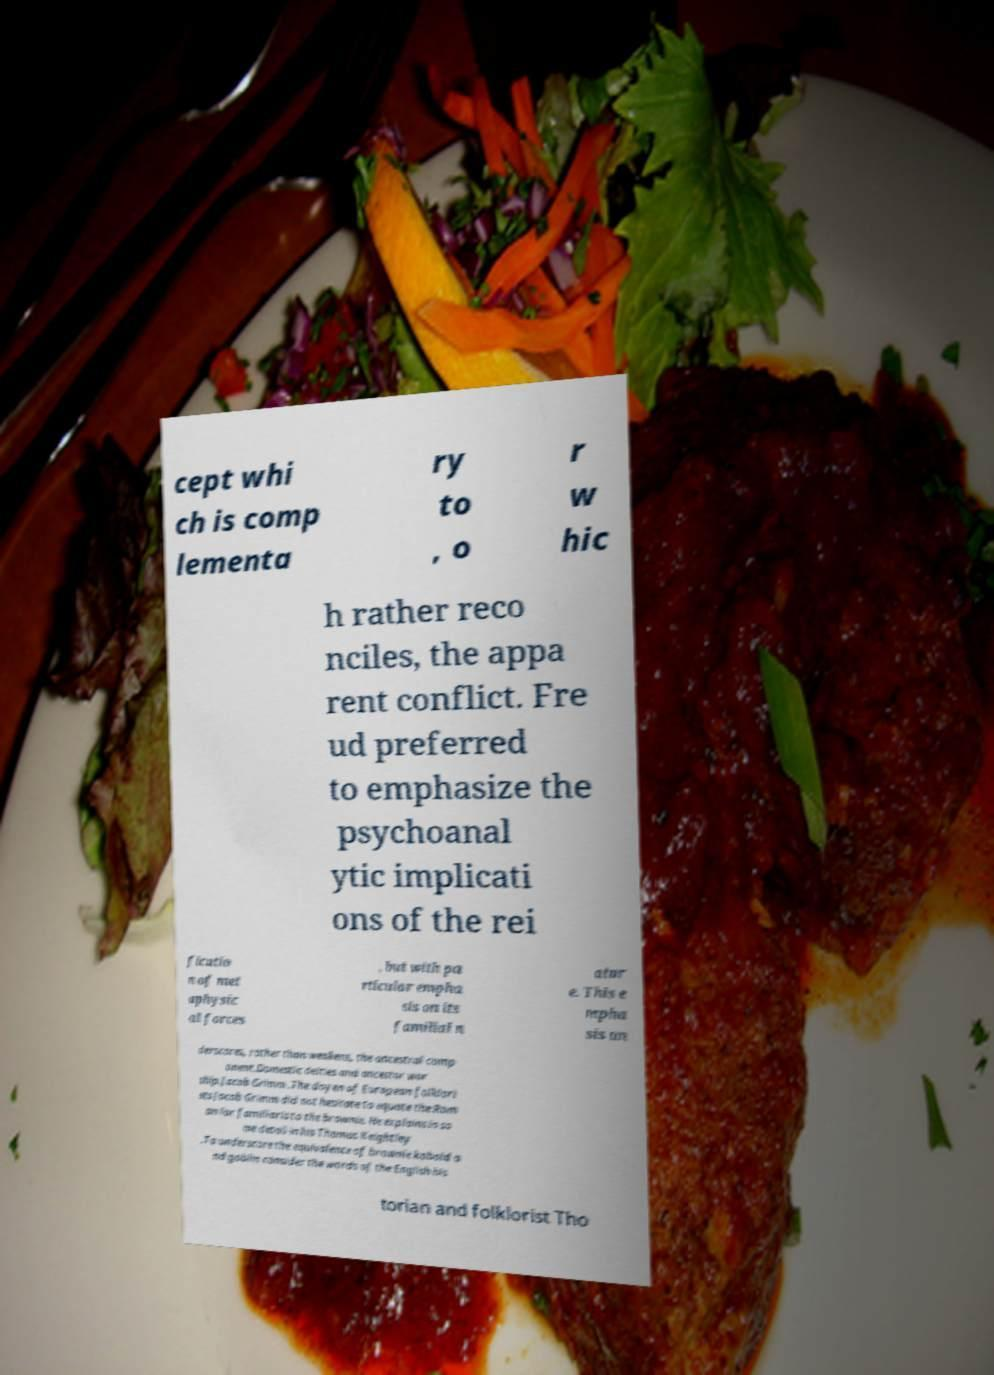Can you accurately transcribe the text from the provided image for me? cept whi ch is comp lementa ry to , o r w hic h rather reco nciles, the appa rent conflict. Fre ud preferred to emphasize the psychoanal ytic implicati ons of the rei ficatio n of met aphysic al forces , but with pa rticular empha sis on its familial n atur e. This e mpha sis un derscores, rather than weakens, the ancestral comp onent.Domestic deities and ancestor wor ship.Jacob Grimm .The doyen of European folklori sts Jacob Grimm did not hesitate to equate the Rom an lar familiaris to the brownie. He explains in so me detail in his Thomas Keightley .To underscore the equivalence of brownie kobold a nd goblin consider the words of the English his torian and folklorist Tho 